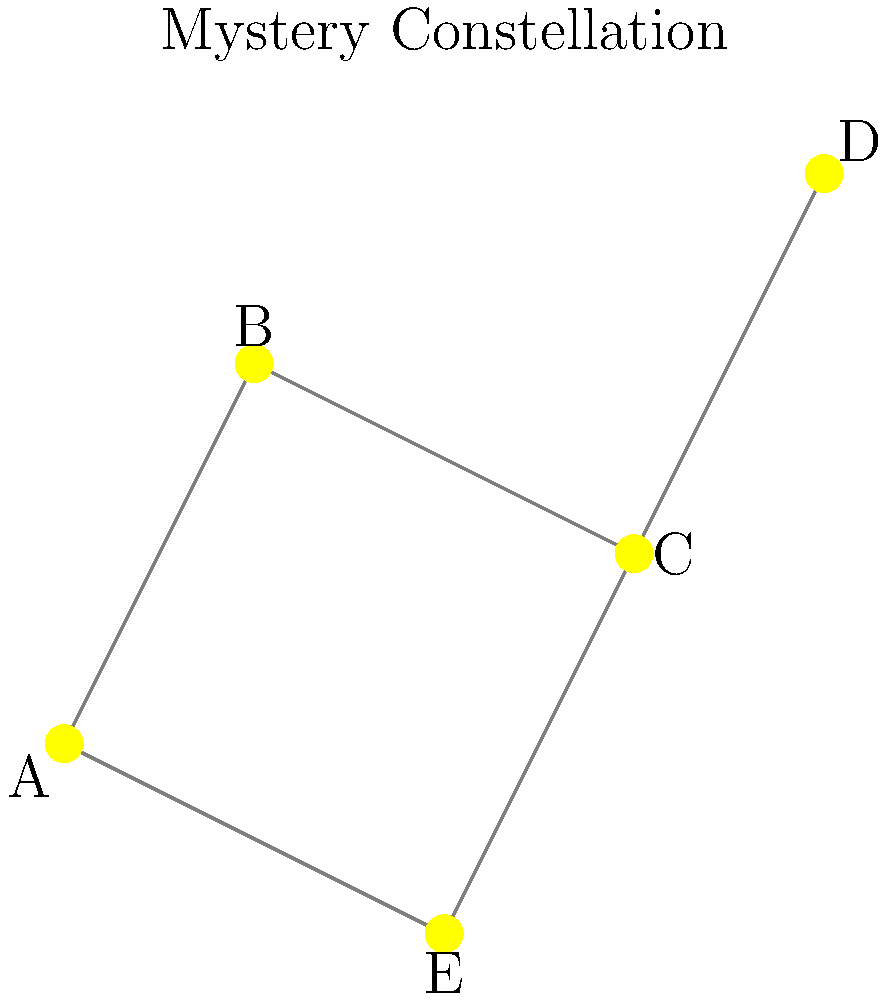In this celestial puzzle reminiscent of connecting the dots in a vintage film reel, identify the well-known constellation depicted by the star pattern and connecting lines. Which iconic celestial formation from ancient mythology does this arrangement represent? To identify this constellation, let's break it down step-by-step:

1. Observe the overall shape: The constellation forms a rough pentagon or house-like shape.

2. Note the distinctive features:
   - There's a prominent "V" shape formed by stars A, B, and C.
   - Stars C, D, and E form a triangle extending from the "V".

3. Consider well-known constellations:
   - The "V" shape is reminiscent of the head of a mythical creature.
   - The triangle could represent a body or wings.

4. Recall constellations with similar shapes:
   - Cygnus (the Swan) has a cross shape, which doesn't match.
   - Orion has a distinctive belt and sword, not present here.
   - Cassiopeia forms a "W" shape, which is different from this pattern.

5. Identify the constellation:
   - The combination of the "V" shape for the head and the triangle for the body is characteristic of Cepheus, the King.
   - In mythology, Cepheus was an Ethiopian king and husband of Cassiopeia.

6. Verify the star pattern:
   - The brightest stars in Cepheus indeed form a shape similar to a house or a child's drawing of a king with a pointed crown (the "V" shape) and a triangular body.

This pattern of stars, with its distinctive "crown" and "body" shape, represents the constellation Cepheus, named after the mythological king.
Answer: Cepheus 